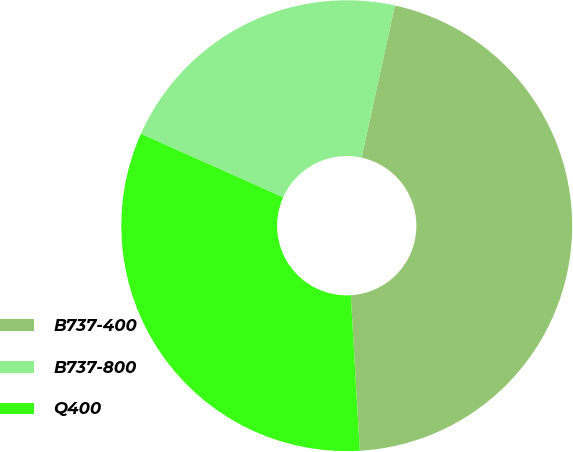Convert chart to OTSL. <chart><loc_0><loc_0><loc_500><loc_500><pie_chart><fcel>B737-400<fcel>B737-800<fcel>Q400<nl><fcel>45.65%<fcel>21.74%<fcel>32.61%<nl></chart> 